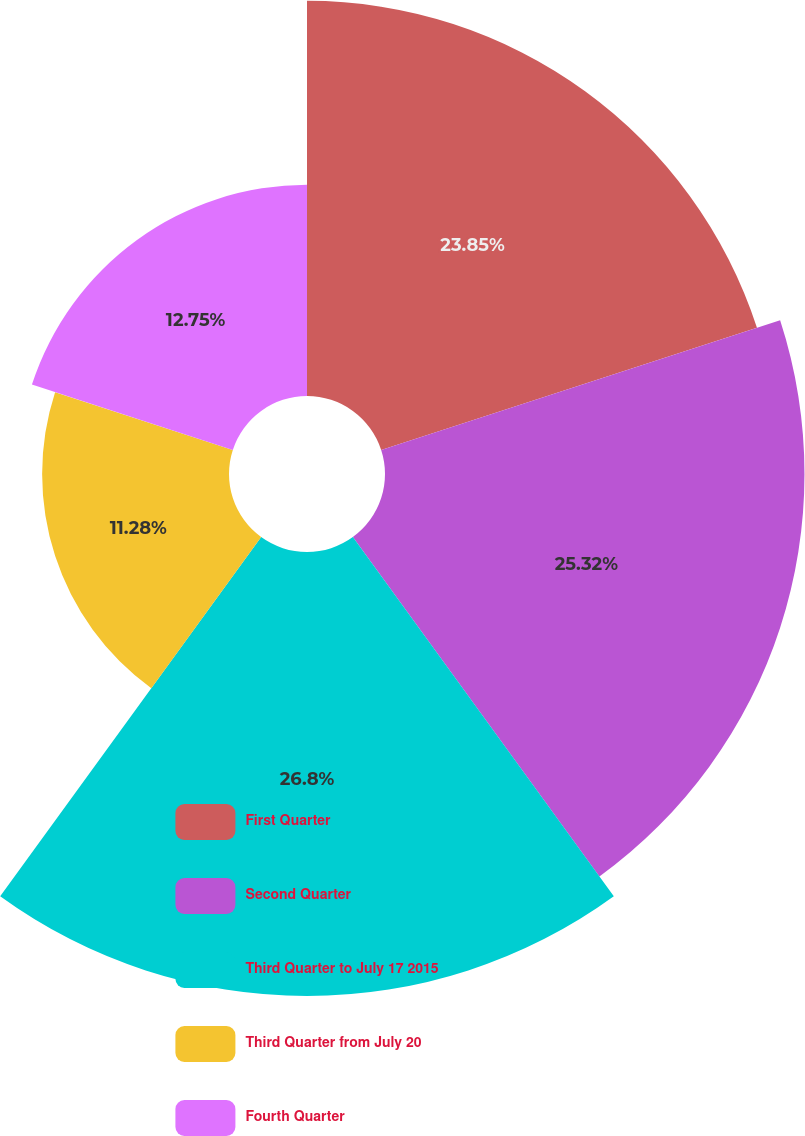Convert chart to OTSL. <chart><loc_0><loc_0><loc_500><loc_500><pie_chart><fcel>First Quarter<fcel>Second Quarter<fcel>Third Quarter to July 17 2015<fcel>Third Quarter from July 20<fcel>Fourth Quarter<nl><fcel>23.85%<fcel>25.32%<fcel>26.8%<fcel>11.28%<fcel>12.75%<nl></chart> 